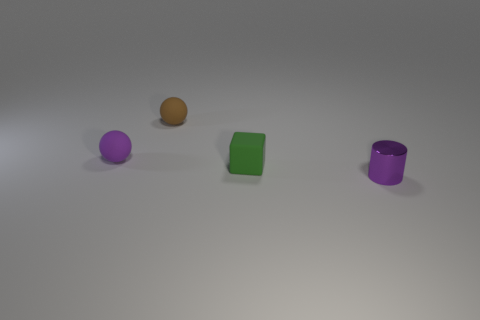There is a purple object to the right of the green matte object; what is it made of?
Provide a short and direct response. Metal. How big is the green matte thing?
Provide a short and direct response. Small. Do the purple object that is behind the shiny object and the object that is to the right of the tiny green rubber object have the same size?
Provide a short and direct response. Yes. There is a purple thing that is the same shape as the small brown object; what size is it?
Give a very brief answer. Small. Is the size of the green matte cube the same as the purple thing that is behind the green matte thing?
Your answer should be compact. Yes. Is there a small sphere behind the matte ball that is left of the brown ball?
Ensure brevity in your answer.  Yes. There is a matte thing that is on the right side of the tiny brown sphere; what is its shape?
Offer a very short reply. Cube. There is another object that is the same color as the metallic thing; what is its material?
Your answer should be compact. Rubber. The tiny ball behind the tiny purple thing left of the shiny thing is what color?
Your answer should be compact. Brown. Is the green object the same size as the purple shiny thing?
Your answer should be very brief. Yes. 